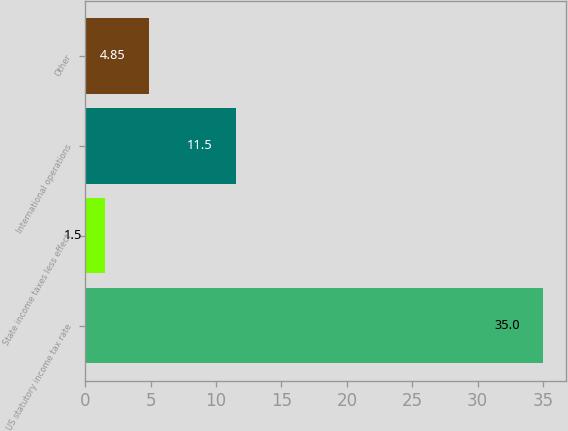<chart> <loc_0><loc_0><loc_500><loc_500><bar_chart><fcel>US statutory income tax rate<fcel>State income taxes less effect<fcel>International operations<fcel>Other<nl><fcel>35<fcel>1.5<fcel>11.5<fcel>4.85<nl></chart> 